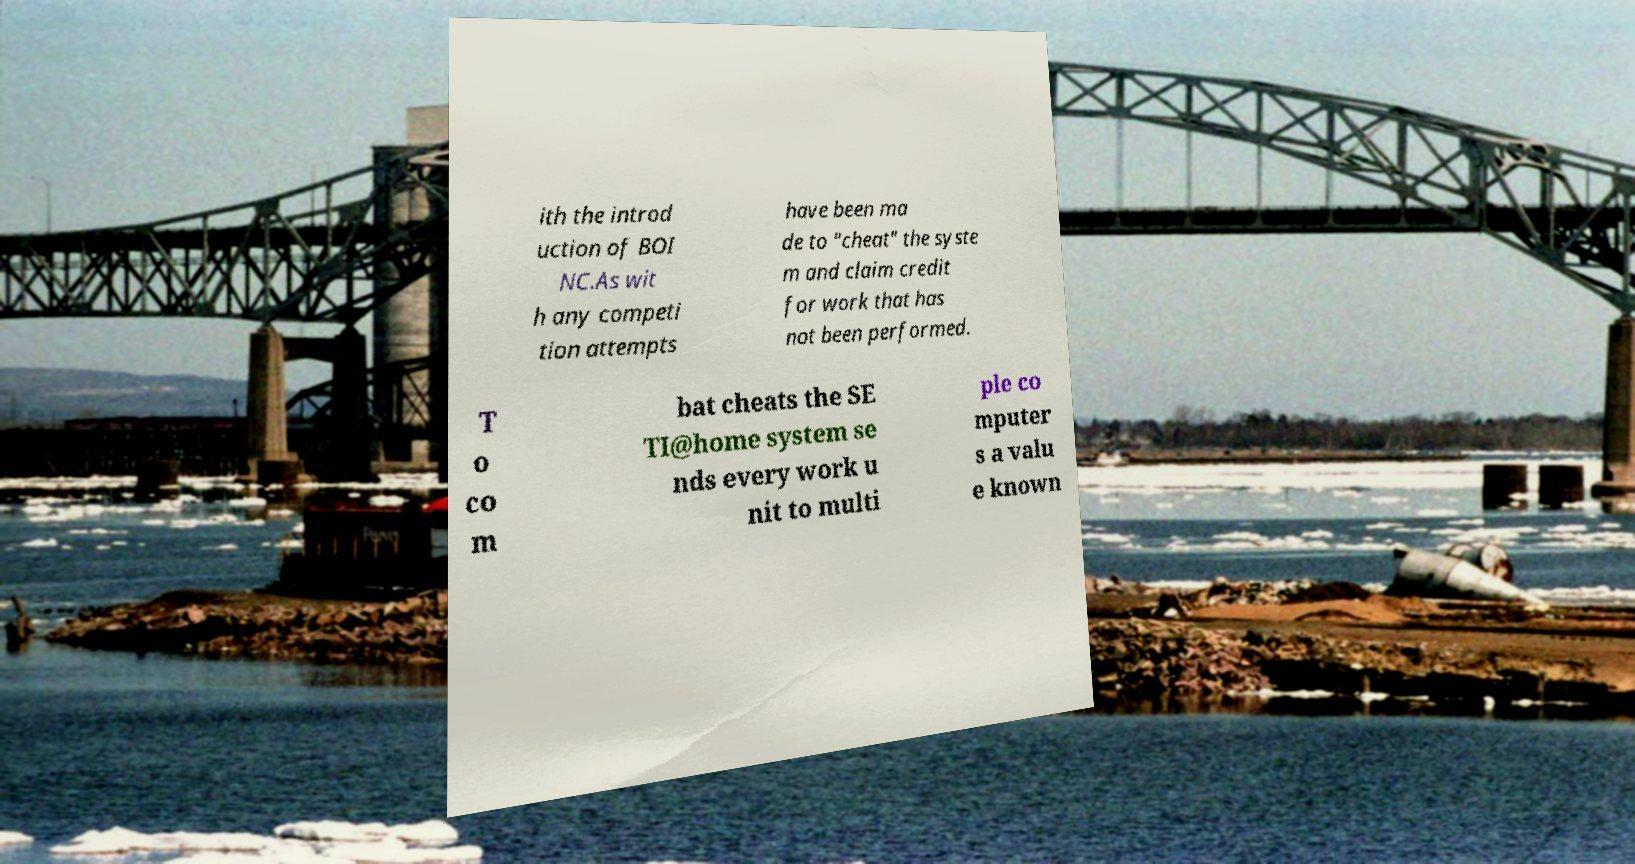I need the written content from this picture converted into text. Can you do that? ith the introd uction of BOI NC.As wit h any competi tion attempts have been ma de to "cheat" the syste m and claim credit for work that has not been performed. T o co m bat cheats the SE TI@home system se nds every work u nit to multi ple co mputer s a valu e known 